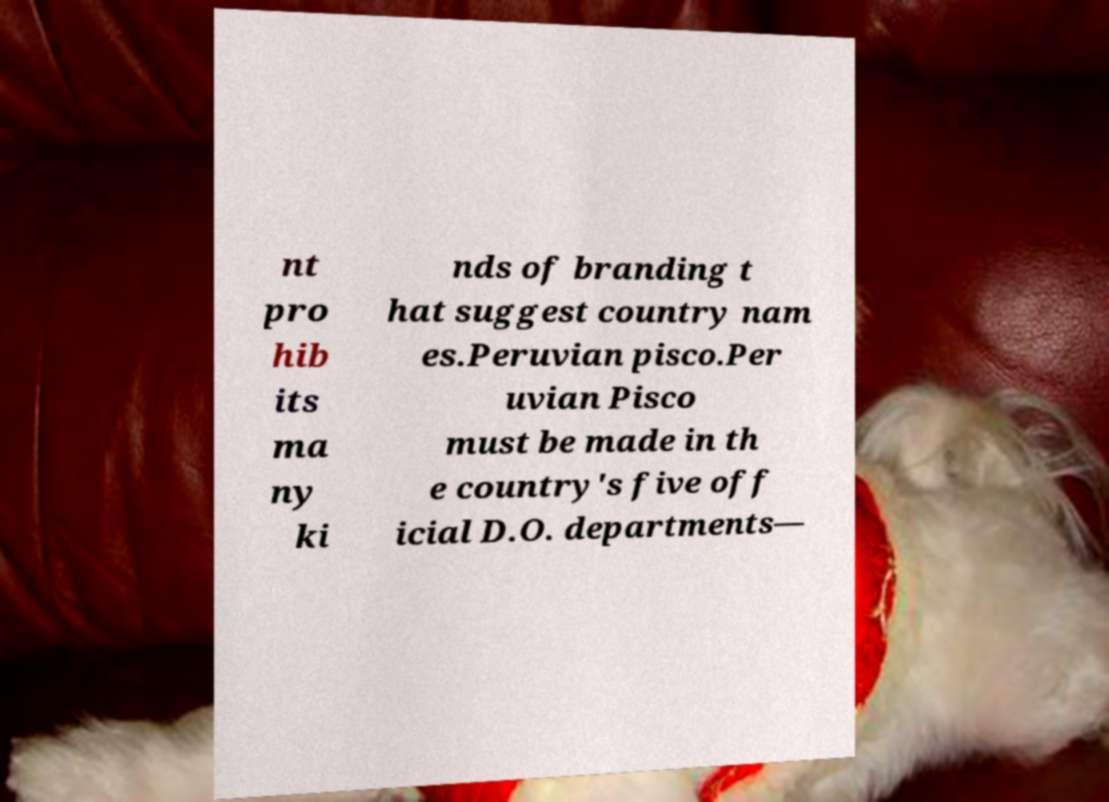Can you accurately transcribe the text from the provided image for me? nt pro hib its ma ny ki nds of branding t hat suggest country nam es.Peruvian pisco.Per uvian Pisco must be made in th e country's five off icial D.O. departments— 